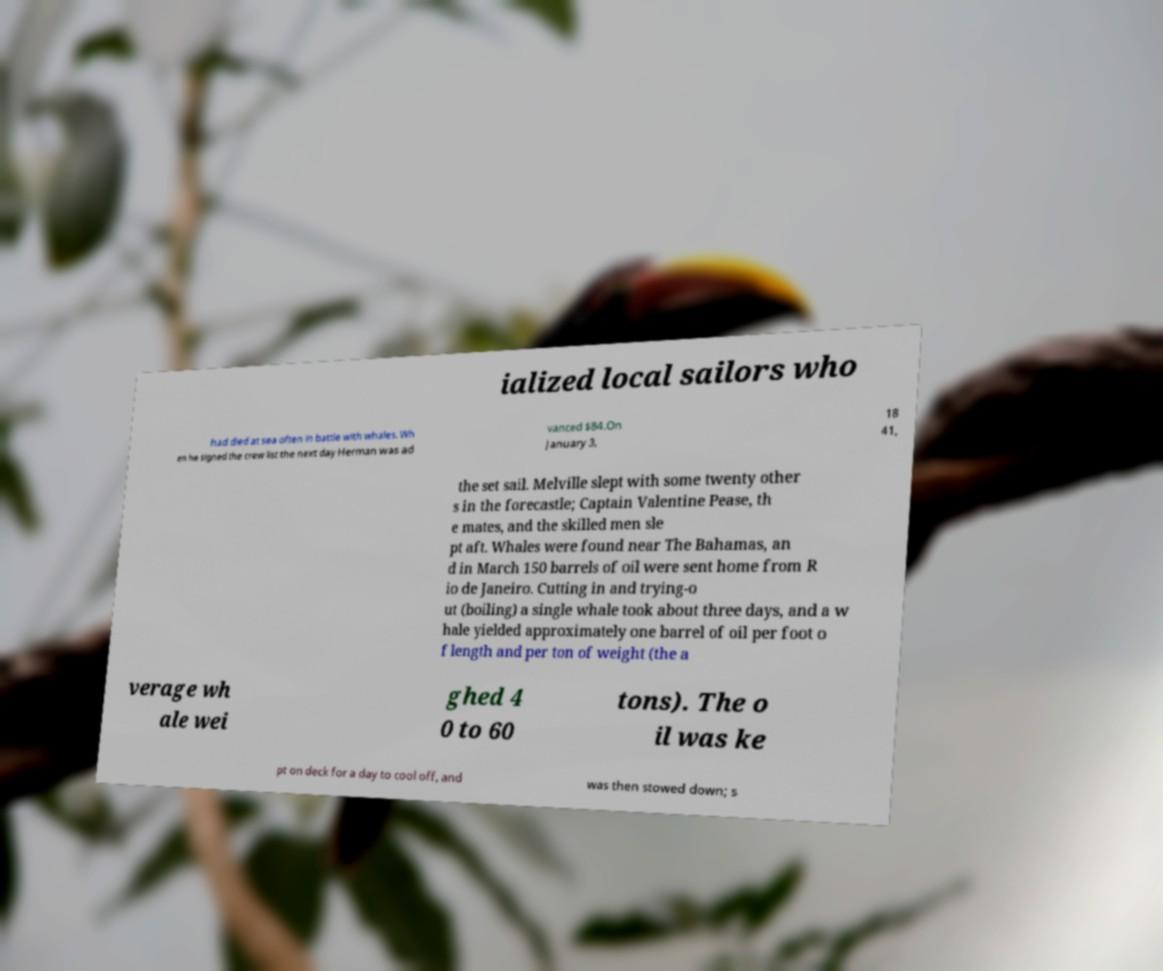There's text embedded in this image that I need extracted. Can you transcribe it verbatim? ialized local sailors who had died at sea often in battle with whales. Wh en he signed the crew list the next day Herman was ad vanced $84.On January 3, 18 41, the set sail. Melville slept with some twenty other s in the forecastle; Captain Valentine Pease, th e mates, and the skilled men sle pt aft. Whales were found near The Bahamas, an d in March 150 barrels of oil were sent home from R io de Janeiro. Cutting in and trying-o ut (boiling) a single whale took about three days, and a w hale yielded approximately one barrel of oil per foot o f length and per ton of weight (the a verage wh ale wei ghed 4 0 to 60 tons). The o il was ke pt on deck for a day to cool off, and was then stowed down; s 